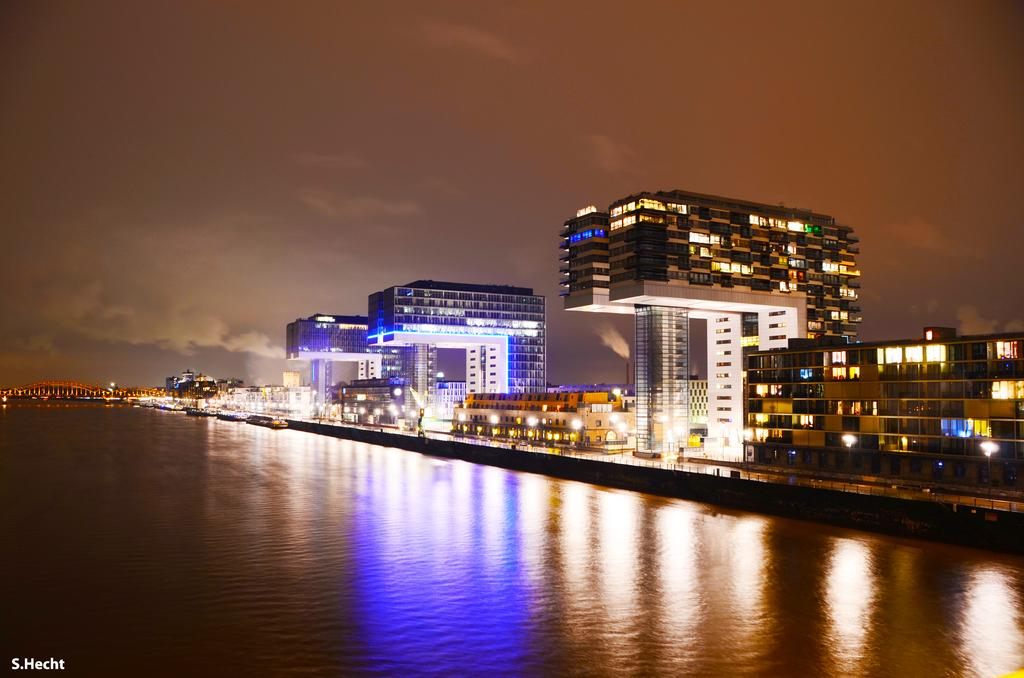What body of water is present in the image? There is a lake in the image. What is floating on the lake? There are boats in the lake. What can be seen in the distance in the image? There are buildings and a bridge in the background of the image. What is visible above the lake and buildings? The sky is visible in the background of the image. Where is the text located in the image? The text is on the bottom left of the left of the image. Where is the family located in the image? There is no family present in the image; it features a lake, boats, buildings, a bridge, the sky, and text. 